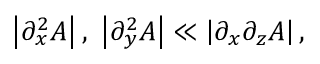<formula> <loc_0><loc_0><loc_500><loc_500>\begin{array} { r } { \left | \partial _ { x } ^ { 2 } A \right | , \ \left | \partial _ { y } ^ { 2 } A \right | \ll \left | \partial _ { x } \partial _ { z } A \right | , } \end{array}</formula> 